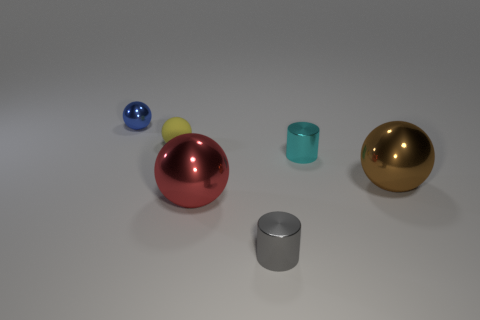Subtract all blue spheres. How many spheres are left? 3 Subtract all metal balls. How many balls are left? 1 Add 2 red things. How many objects exist? 8 Subtract all green spheres. Subtract all brown cylinders. How many spheres are left? 4 Subtract all spheres. How many objects are left? 2 Subtract 0 gray spheres. How many objects are left? 6 Subtract all brown metal objects. Subtract all big metal objects. How many objects are left? 3 Add 3 rubber objects. How many rubber objects are left? 4 Add 5 small red things. How many small red things exist? 5 